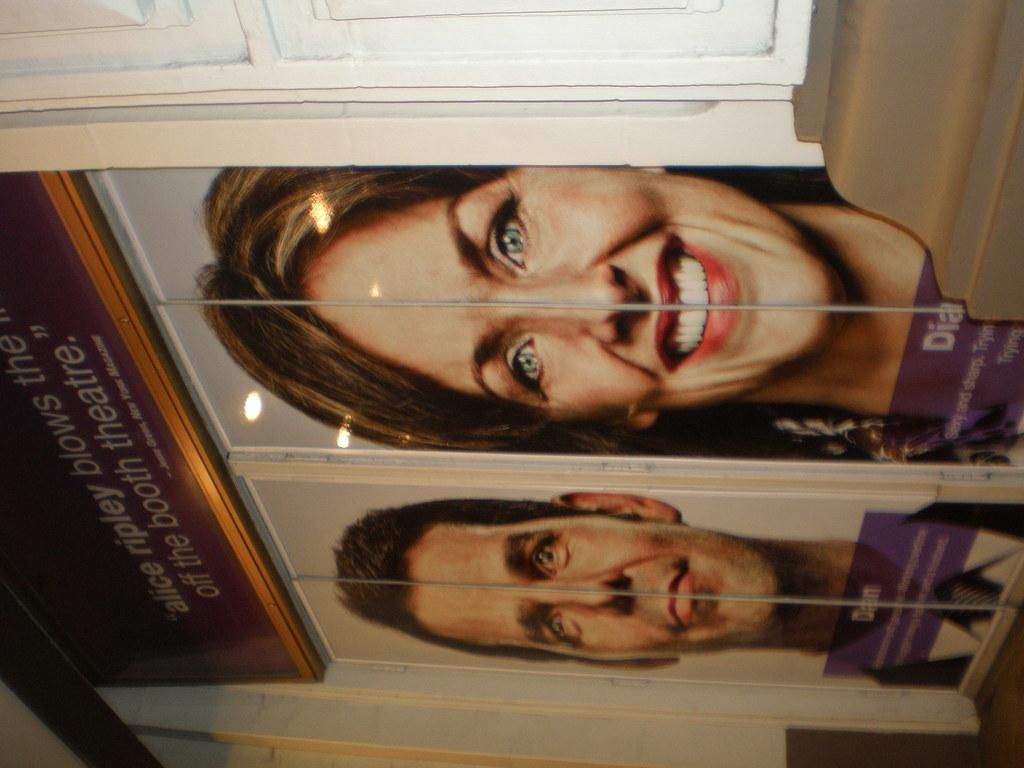What is present on the wall in the image? There is a wall in the image with two doors on it. What can be seen on the doors? There are pictures of a man and a woman on the doors. Is there any text on the doors? Yes, there is text on the top of the doors. What type of chalk is being used to draw on the doors in the image? There is no chalk present in the image, and no drawing activity is taking place on the doors. 